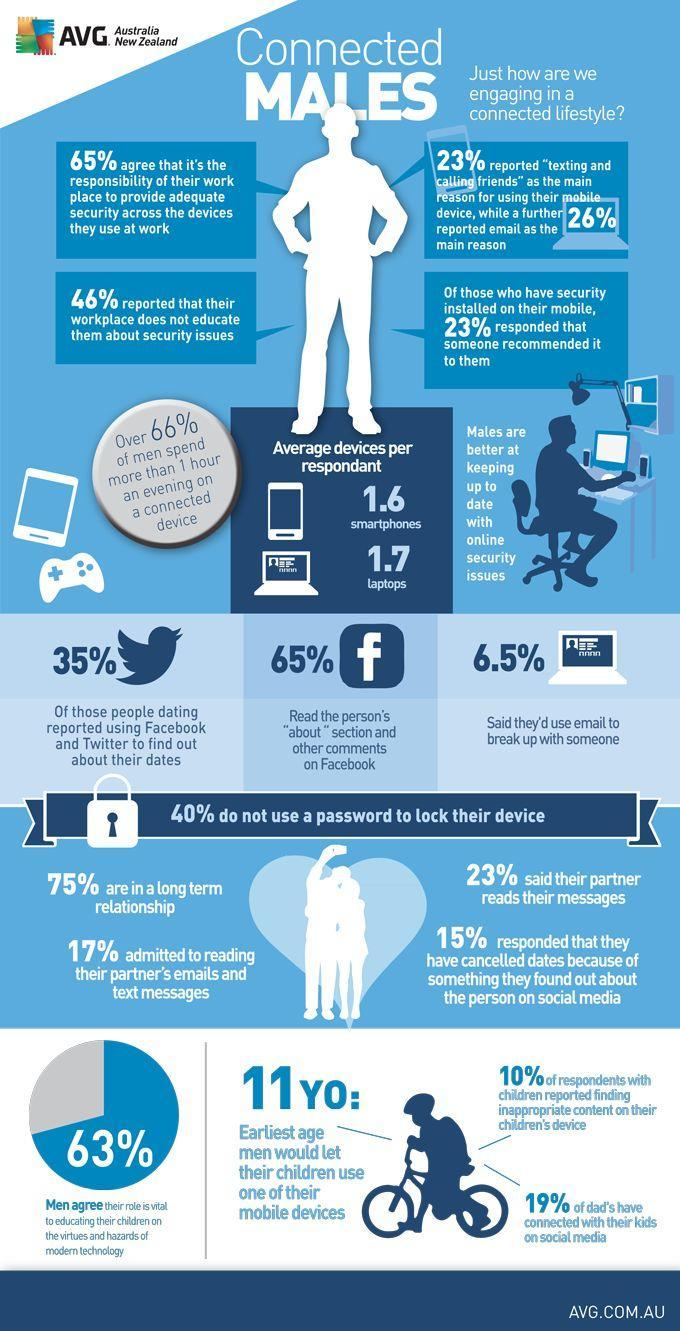What percentage of dads have not connected with their kids on social media?
Answer the question with a short phrase. 81% What percentage of males are not in a long term relationship? 25% What percentage reported that their workplace does educate them about security issues? 54% What percentage use email to break up with someone? 6.5% 